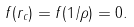<formula> <loc_0><loc_0><loc_500><loc_500>f ( r _ { c } ) = f ( 1 / \rho ) = 0 .</formula> 